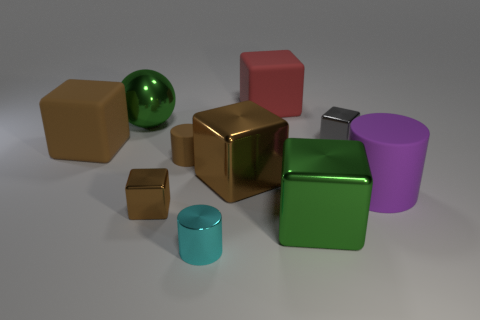Subtract all purple cylinders. How many brown cubes are left? 3 Subtract all small brown metallic cubes. How many cubes are left? 5 Subtract 2 cubes. How many cubes are left? 4 Subtract all red blocks. How many blocks are left? 5 Subtract all red cubes. Subtract all cyan cylinders. How many cubes are left? 5 Subtract all cylinders. How many objects are left? 7 Subtract 0 yellow cylinders. How many objects are left? 10 Subtract all gray shiny cubes. Subtract all matte things. How many objects are left? 5 Add 4 brown objects. How many brown objects are left? 8 Add 6 small brown rubber things. How many small brown rubber things exist? 7 